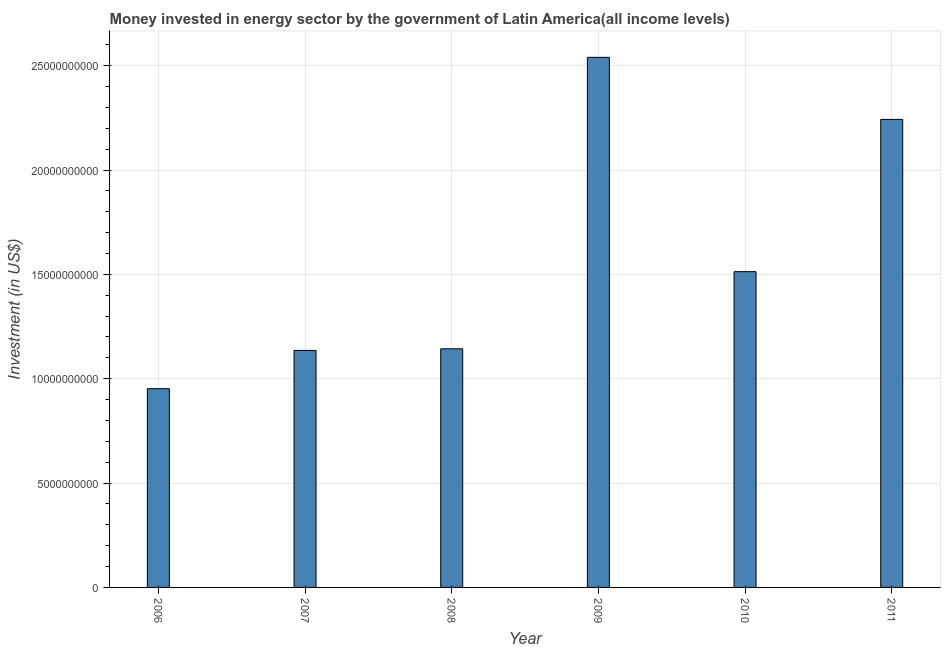Does the graph contain grids?
Provide a short and direct response. Yes. What is the title of the graph?
Your answer should be compact. Money invested in energy sector by the government of Latin America(all income levels). What is the label or title of the X-axis?
Your answer should be compact. Year. What is the label or title of the Y-axis?
Provide a succinct answer. Investment (in US$). What is the investment in energy in 2010?
Keep it short and to the point. 1.51e+1. Across all years, what is the maximum investment in energy?
Offer a terse response. 2.54e+1. Across all years, what is the minimum investment in energy?
Offer a terse response. 9.52e+09. What is the sum of the investment in energy?
Offer a very short reply. 9.53e+1. What is the difference between the investment in energy in 2009 and 2011?
Your answer should be compact. 2.97e+09. What is the average investment in energy per year?
Give a very brief answer. 1.59e+1. What is the median investment in energy?
Provide a short and direct response. 1.33e+1. In how many years, is the investment in energy greater than 8000000000 US$?
Provide a succinct answer. 6. Is the difference between the investment in energy in 2006 and 2008 greater than the difference between any two years?
Your answer should be compact. No. What is the difference between the highest and the second highest investment in energy?
Keep it short and to the point. 2.97e+09. What is the difference between the highest and the lowest investment in energy?
Your answer should be very brief. 1.59e+1. What is the difference between two consecutive major ticks on the Y-axis?
Offer a terse response. 5.00e+09. Are the values on the major ticks of Y-axis written in scientific E-notation?
Offer a terse response. No. What is the Investment (in US$) of 2006?
Give a very brief answer. 9.52e+09. What is the Investment (in US$) of 2007?
Offer a terse response. 1.14e+1. What is the Investment (in US$) of 2008?
Make the answer very short. 1.14e+1. What is the Investment (in US$) of 2009?
Your response must be concise. 2.54e+1. What is the Investment (in US$) in 2010?
Your response must be concise. 1.51e+1. What is the Investment (in US$) of 2011?
Your answer should be compact. 2.24e+1. What is the difference between the Investment (in US$) in 2006 and 2007?
Give a very brief answer. -1.83e+09. What is the difference between the Investment (in US$) in 2006 and 2008?
Make the answer very short. -1.91e+09. What is the difference between the Investment (in US$) in 2006 and 2009?
Keep it short and to the point. -1.59e+1. What is the difference between the Investment (in US$) in 2006 and 2010?
Your answer should be compact. -5.61e+09. What is the difference between the Investment (in US$) in 2006 and 2011?
Offer a very short reply. -1.29e+1. What is the difference between the Investment (in US$) in 2007 and 2008?
Your answer should be very brief. -7.74e+07. What is the difference between the Investment (in US$) in 2007 and 2009?
Provide a succinct answer. -1.40e+1. What is the difference between the Investment (in US$) in 2007 and 2010?
Your answer should be compact. -3.77e+09. What is the difference between the Investment (in US$) in 2007 and 2011?
Provide a short and direct response. -1.11e+1. What is the difference between the Investment (in US$) in 2008 and 2009?
Provide a succinct answer. -1.40e+1. What is the difference between the Investment (in US$) in 2008 and 2010?
Provide a succinct answer. -3.70e+09. What is the difference between the Investment (in US$) in 2008 and 2011?
Ensure brevity in your answer.  -1.10e+1. What is the difference between the Investment (in US$) in 2009 and 2010?
Offer a terse response. 1.03e+1. What is the difference between the Investment (in US$) in 2009 and 2011?
Make the answer very short. 2.97e+09. What is the difference between the Investment (in US$) in 2010 and 2011?
Your response must be concise. -7.30e+09. What is the ratio of the Investment (in US$) in 2006 to that in 2007?
Provide a succinct answer. 0.84. What is the ratio of the Investment (in US$) in 2006 to that in 2008?
Keep it short and to the point. 0.83. What is the ratio of the Investment (in US$) in 2006 to that in 2009?
Your response must be concise. 0.38. What is the ratio of the Investment (in US$) in 2006 to that in 2010?
Provide a short and direct response. 0.63. What is the ratio of the Investment (in US$) in 2006 to that in 2011?
Offer a very short reply. 0.42. What is the ratio of the Investment (in US$) in 2007 to that in 2009?
Provide a succinct answer. 0.45. What is the ratio of the Investment (in US$) in 2007 to that in 2010?
Ensure brevity in your answer.  0.75. What is the ratio of the Investment (in US$) in 2007 to that in 2011?
Provide a short and direct response. 0.51. What is the ratio of the Investment (in US$) in 2008 to that in 2009?
Provide a short and direct response. 0.45. What is the ratio of the Investment (in US$) in 2008 to that in 2010?
Your answer should be compact. 0.76. What is the ratio of the Investment (in US$) in 2008 to that in 2011?
Keep it short and to the point. 0.51. What is the ratio of the Investment (in US$) in 2009 to that in 2010?
Ensure brevity in your answer.  1.68. What is the ratio of the Investment (in US$) in 2009 to that in 2011?
Give a very brief answer. 1.13. What is the ratio of the Investment (in US$) in 2010 to that in 2011?
Offer a very short reply. 0.68. 